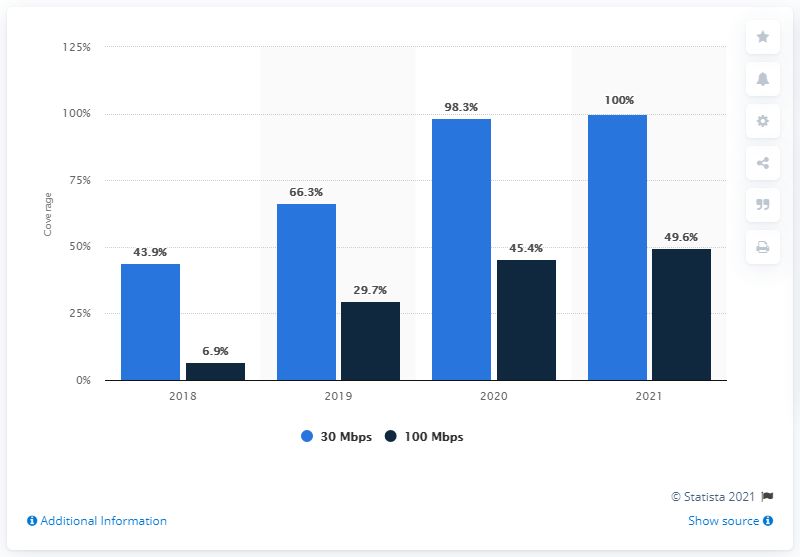List a handful of essential elements in this visual. A 30 Mbps connection speed is considered to be the fastest and most reliable, with 100% performance. The speed with the slowest connection speed is 100 Mbps. In Abruzzo in the year 2018, the highest connection speed was 30 Mbps. 